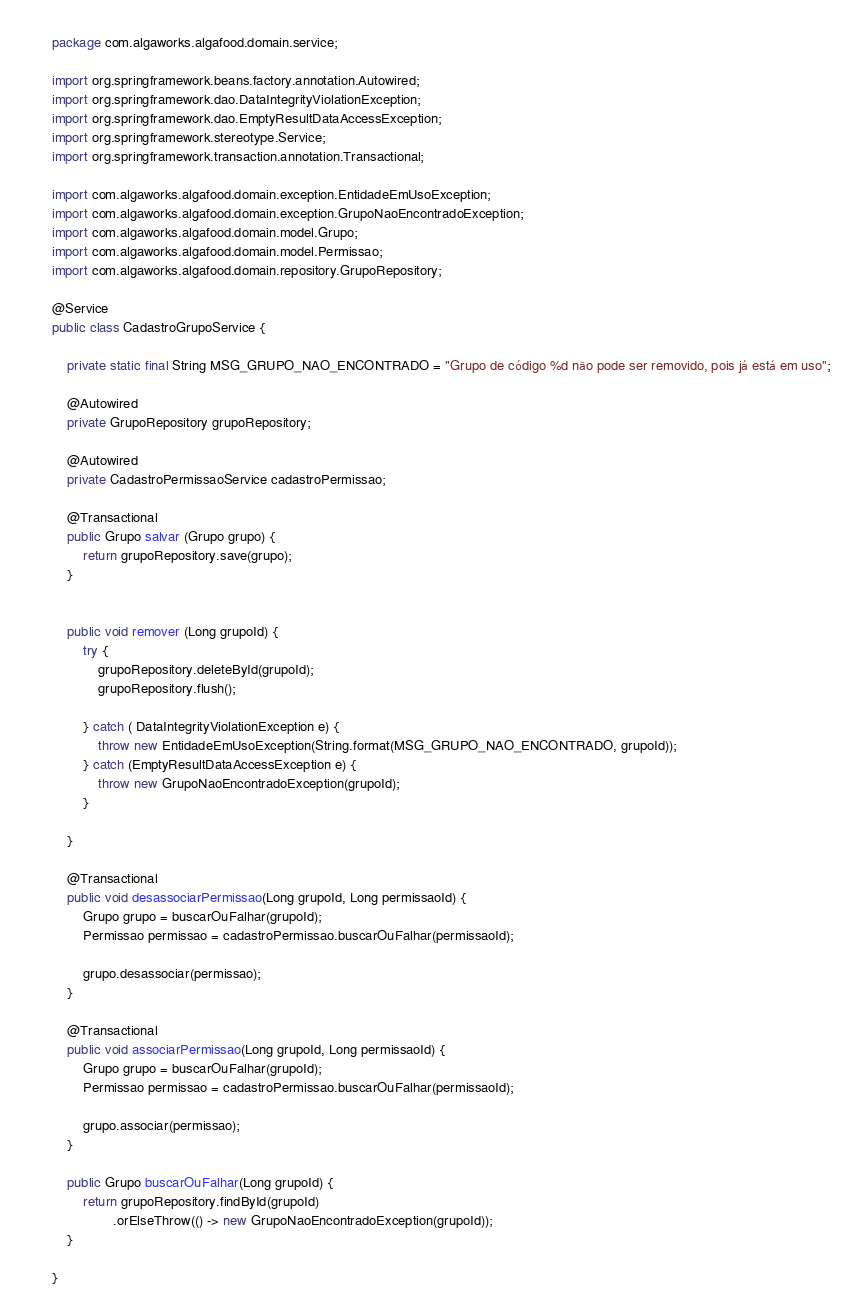<code> <loc_0><loc_0><loc_500><loc_500><_Java_>package com.algaworks.algafood.domain.service;

import org.springframework.beans.factory.annotation.Autowired;
import org.springframework.dao.DataIntegrityViolationException;
import org.springframework.dao.EmptyResultDataAccessException;
import org.springframework.stereotype.Service;
import org.springframework.transaction.annotation.Transactional;

import com.algaworks.algafood.domain.exception.EntidadeEmUsoException;
import com.algaworks.algafood.domain.exception.GrupoNaoEncontradoException;
import com.algaworks.algafood.domain.model.Grupo;
import com.algaworks.algafood.domain.model.Permissao;
import com.algaworks.algafood.domain.repository.GrupoRepository;

@Service
public class CadastroGrupoService {
	
	private static final String MSG_GRUPO_NAO_ENCONTRADO = "Grupo de código %d não pode ser removido, pois já está em uso";
	
	@Autowired
	private GrupoRepository grupoRepository;
	
	@Autowired
	private CadastroPermissaoService cadastroPermissao;
	
	@Transactional
	public Grupo salvar (Grupo grupo) {
		return grupoRepository.save(grupo);
	}
	
	
	public void remover (Long grupoId) {
		try {
			grupoRepository.deleteById(grupoId);
			grupoRepository.flush();
			
		} catch ( DataIntegrityViolationException e) {
			throw new EntidadeEmUsoException(String.format(MSG_GRUPO_NAO_ENCONTRADO, grupoId));
		} catch (EmptyResultDataAccessException e) {
			throw new GrupoNaoEncontradoException(grupoId);
		}
		
	}
	
	@Transactional
	public void desassociarPermissao(Long grupoId, Long permissaoId) {
		Grupo grupo = buscarOuFalhar(grupoId);
		Permissao permissao = cadastroPermissao.buscarOuFalhar(permissaoId);

		grupo.desassociar(permissao);
	}
	
	@Transactional
	public void associarPermissao(Long grupoId, Long permissaoId) {
		Grupo grupo = buscarOuFalhar(grupoId);
		Permissao permissao = cadastroPermissao.buscarOuFalhar(permissaoId);

		grupo.associar(permissao);
	}
	
	public Grupo buscarOuFalhar(Long grupoId) {
		return grupoRepository.findById(grupoId)
				.orElseThrow(() -> new GrupoNaoEncontradoException(grupoId));
	}

}
</code> 